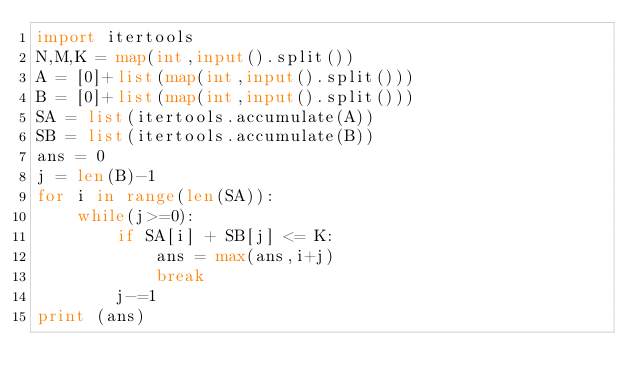<code> <loc_0><loc_0><loc_500><loc_500><_Python_>import itertools
N,M,K = map(int,input().split())
A = [0]+list(map(int,input().split()))
B = [0]+list(map(int,input().split()))
SA = list(itertools.accumulate(A))
SB = list(itertools.accumulate(B))
ans = 0
j = len(B)-1
for i in range(len(SA)):
    while(j>=0):
        if SA[i] + SB[j] <= K:
            ans = max(ans,i+j)
            break
        j-=1
print (ans)</code> 